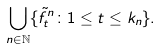<formula> <loc_0><loc_0><loc_500><loc_500>\bigcup _ { n \in \mathbb { N } } \{ \tilde { f } ^ { n } _ { t } \colon 1 \leq t \leq k _ { n } \} .</formula> 